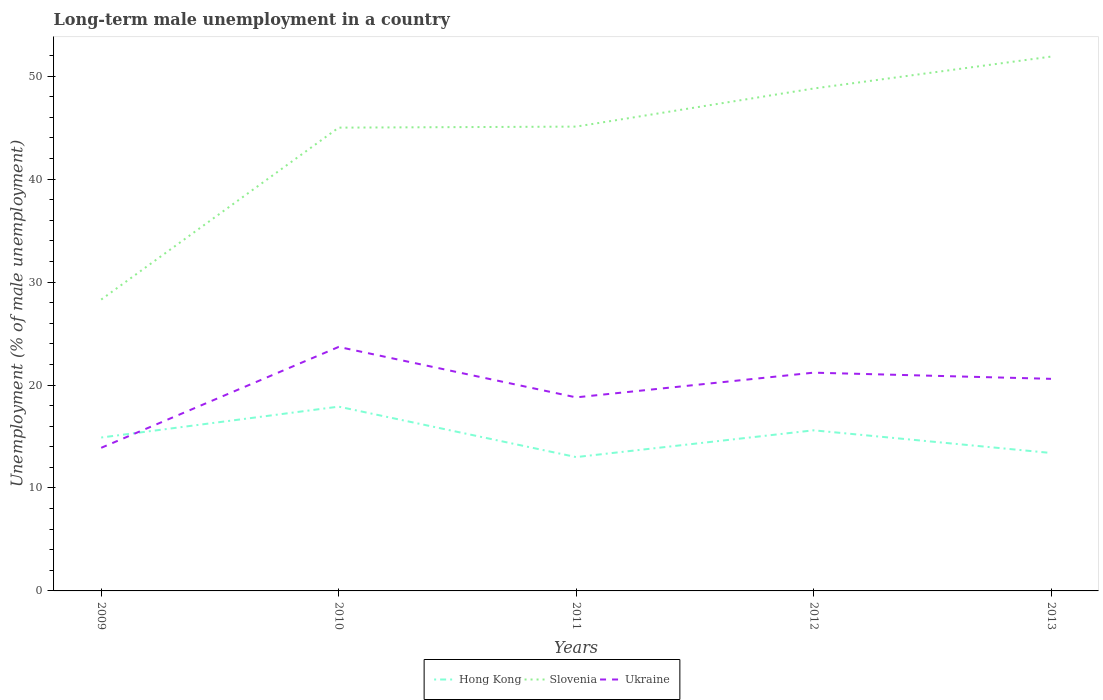How many different coloured lines are there?
Your answer should be compact. 3. Does the line corresponding to Hong Kong intersect with the line corresponding to Slovenia?
Provide a succinct answer. No. Is the number of lines equal to the number of legend labels?
Offer a terse response. Yes. Across all years, what is the maximum percentage of long-term unemployed male population in Hong Kong?
Your answer should be compact. 13. In which year was the percentage of long-term unemployed male population in Hong Kong maximum?
Your response must be concise. 2011. What is the total percentage of long-term unemployed male population in Hong Kong in the graph?
Offer a very short reply. 2.3. What is the difference between the highest and the second highest percentage of long-term unemployed male population in Slovenia?
Provide a short and direct response. 23.6. What is the difference between the highest and the lowest percentage of long-term unemployed male population in Slovenia?
Provide a short and direct response. 4. Is the percentage of long-term unemployed male population in Slovenia strictly greater than the percentage of long-term unemployed male population in Hong Kong over the years?
Your response must be concise. No. How many years are there in the graph?
Give a very brief answer. 5. Where does the legend appear in the graph?
Your response must be concise. Bottom center. How are the legend labels stacked?
Offer a terse response. Horizontal. What is the title of the graph?
Keep it short and to the point. Long-term male unemployment in a country. What is the label or title of the X-axis?
Ensure brevity in your answer.  Years. What is the label or title of the Y-axis?
Your answer should be compact. Unemployment (% of male unemployment). What is the Unemployment (% of male unemployment) of Hong Kong in 2009?
Ensure brevity in your answer.  14.9. What is the Unemployment (% of male unemployment) in Slovenia in 2009?
Provide a short and direct response. 28.3. What is the Unemployment (% of male unemployment) in Ukraine in 2009?
Make the answer very short. 13.9. What is the Unemployment (% of male unemployment) of Hong Kong in 2010?
Offer a very short reply. 17.9. What is the Unemployment (% of male unemployment) in Ukraine in 2010?
Your answer should be very brief. 23.7. What is the Unemployment (% of male unemployment) in Slovenia in 2011?
Offer a very short reply. 45.1. What is the Unemployment (% of male unemployment) in Ukraine in 2011?
Keep it short and to the point. 18.8. What is the Unemployment (% of male unemployment) of Hong Kong in 2012?
Your answer should be compact. 15.6. What is the Unemployment (% of male unemployment) in Slovenia in 2012?
Your response must be concise. 48.8. What is the Unemployment (% of male unemployment) in Ukraine in 2012?
Your answer should be very brief. 21.2. What is the Unemployment (% of male unemployment) in Hong Kong in 2013?
Give a very brief answer. 13.4. What is the Unemployment (% of male unemployment) of Slovenia in 2013?
Offer a very short reply. 51.9. What is the Unemployment (% of male unemployment) of Ukraine in 2013?
Provide a short and direct response. 20.6. Across all years, what is the maximum Unemployment (% of male unemployment) in Hong Kong?
Your response must be concise. 17.9. Across all years, what is the maximum Unemployment (% of male unemployment) in Slovenia?
Offer a terse response. 51.9. Across all years, what is the maximum Unemployment (% of male unemployment) of Ukraine?
Keep it short and to the point. 23.7. Across all years, what is the minimum Unemployment (% of male unemployment) of Hong Kong?
Offer a terse response. 13. Across all years, what is the minimum Unemployment (% of male unemployment) of Slovenia?
Your answer should be compact. 28.3. Across all years, what is the minimum Unemployment (% of male unemployment) in Ukraine?
Provide a short and direct response. 13.9. What is the total Unemployment (% of male unemployment) of Hong Kong in the graph?
Provide a short and direct response. 74.8. What is the total Unemployment (% of male unemployment) in Slovenia in the graph?
Provide a short and direct response. 219.1. What is the total Unemployment (% of male unemployment) in Ukraine in the graph?
Your response must be concise. 98.2. What is the difference between the Unemployment (% of male unemployment) of Slovenia in 2009 and that in 2010?
Your answer should be compact. -16.7. What is the difference between the Unemployment (% of male unemployment) of Ukraine in 2009 and that in 2010?
Make the answer very short. -9.8. What is the difference between the Unemployment (% of male unemployment) in Slovenia in 2009 and that in 2011?
Ensure brevity in your answer.  -16.8. What is the difference between the Unemployment (% of male unemployment) in Ukraine in 2009 and that in 2011?
Give a very brief answer. -4.9. What is the difference between the Unemployment (% of male unemployment) in Slovenia in 2009 and that in 2012?
Provide a succinct answer. -20.5. What is the difference between the Unemployment (% of male unemployment) in Hong Kong in 2009 and that in 2013?
Your answer should be compact. 1.5. What is the difference between the Unemployment (% of male unemployment) in Slovenia in 2009 and that in 2013?
Your answer should be very brief. -23.6. What is the difference between the Unemployment (% of male unemployment) in Ukraine in 2009 and that in 2013?
Keep it short and to the point. -6.7. What is the difference between the Unemployment (% of male unemployment) in Hong Kong in 2010 and that in 2011?
Provide a short and direct response. 4.9. What is the difference between the Unemployment (% of male unemployment) of Hong Kong in 2010 and that in 2012?
Offer a terse response. 2.3. What is the difference between the Unemployment (% of male unemployment) of Slovenia in 2010 and that in 2012?
Your answer should be very brief. -3.8. What is the difference between the Unemployment (% of male unemployment) of Ukraine in 2010 and that in 2012?
Your response must be concise. 2.5. What is the difference between the Unemployment (% of male unemployment) in Hong Kong in 2011 and that in 2012?
Give a very brief answer. -2.6. What is the difference between the Unemployment (% of male unemployment) of Slovenia in 2011 and that in 2012?
Offer a very short reply. -3.7. What is the difference between the Unemployment (% of male unemployment) in Ukraine in 2011 and that in 2012?
Provide a succinct answer. -2.4. What is the difference between the Unemployment (% of male unemployment) in Hong Kong in 2011 and that in 2013?
Provide a succinct answer. -0.4. What is the difference between the Unemployment (% of male unemployment) in Ukraine in 2011 and that in 2013?
Provide a succinct answer. -1.8. What is the difference between the Unemployment (% of male unemployment) of Slovenia in 2012 and that in 2013?
Your answer should be compact. -3.1. What is the difference between the Unemployment (% of male unemployment) in Ukraine in 2012 and that in 2013?
Offer a terse response. 0.6. What is the difference between the Unemployment (% of male unemployment) in Hong Kong in 2009 and the Unemployment (% of male unemployment) in Slovenia in 2010?
Ensure brevity in your answer.  -30.1. What is the difference between the Unemployment (% of male unemployment) in Hong Kong in 2009 and the Unemployment (% of male unemployment) in Slovenia in 2011?
Ensure brevity in your answer.  -30.2. What is the difference between the Unemployment (% of male unemployment) in Hong Kong in 2009 and the Unemployment (% of male unemployment) in Slovenia in 2012?
Make the answer very short. -33.9. What is the difference between the Unemployment (% of male unemployment) of Hong Kong in 2009 and the Unemployment (% of male unemployment) of Ukraine in 2012?
Offer a terse response. -6.3. What is the difference between the Unemployment (% of male unemployment) in Hong Kong in 2009 and the Unemployment (% of male unemployment) in Slovenia in 2013?
Make the answer very short. -37. What is the difference between the Unemployment (% of male unemployment) of Hong Kong in 2010 and the Unemployment (% of male unemployment) of Slovenia in 2011?
Your response must be concise. -27.2. What is the difference between the Unemployment (% of male unemployment) of Slovenia in 2010 and the Unemployment (% of male unemployment) of Ukraine in 2011?
Provide a succinct answer. 26.2. What is the difference between the Unemployment (% of male unemployment) of Hong Kong in 2010 and the Unemployment (% of male unemployment) of Slovenia in 2012?
Your response must be concise. -30.9. What is the difference between the Unemployment (% of male unemployment) of Hong Kong in 2010 and the Unemployment (% of male unemployment) of Ukraine in 2012?
Offer a very short reply. -3.3. What is the difference between the Unemployment (% of male unemployment) in Slovenia in 2010 and the Unemployment (% of male unemployment) in Ukraine in 2012?
Ensure brevity in your answer.  23.8. What is the difference between the Unemployment (% of male unemployment) in Hong Kong in 2010 and the Unemployment (% of male unemployment) in Slovenia in 2013?
Your response must be concise. -34. What is the difference between the Unemployment (% of male unemployment) of Slovenia in 2010 and the Unemployment (% of male unemployment) of Ukraine in 2013?
Ensure brevity in your answer.  24.4. What is the difference between the Unemployment (% of male unemployment) of Hong Kong in 2011 and the Unemployment (% of male unemployment) of Slovenia in 2012?
Your answer should be very brief. -35.8. What is the difference between the Unemployment (% of male unemployment) in Slovenia in 2011 and the Unemployment (% of male unemployment) in Ukraine in 2012?
Offer a terse response. 23.9. What is the difference between the Unemployment (% of male unemployment) in Hong Kong in 2011 and the Unemployment (% of male unemployment) in Slovenia in 2013?
Keep it short and to the point. -38.9. What is the difference between the Unemployment (% of male unemployment) of Hong Kong in 2012 and the Unemployment (% of male unemployment) of Slovenia in 2013?
Keep it short and to the point. -36.3. What is the difference between the Unemployment (% of male unemployment) in Slovenia in 2012 and the Unemployment (% of male unemployment) in Ukraine in 2013?
Offer a very short reply. 28.2. What is the average Unemployment (% of male unemployment) of Hong Kong per year?
Make the answer very short. 14.96. What is the average Unemployment (% of male unemployment) in Slovenia per year?
Give a very brief answer. 43.82. What is the average Unemployment (% of male unemployment) of Ukraine per year?
Keep it short and to the point. 19.64. In the year 2009, what is the difference between the Unemployment (% of male unemployment) in Hong Kong and Unemployment (% of male unemployment) in Ukraine?
Provide a short and direct response. 1. In the year 2010, what is the difference between the Unemployment (% of male unemployment) in Hong Kong and Unemployment (% of male unemployment) in Slovenia?
Ensure brevity in your answer.  -27.1. In the year 2010, what is the difference between the Unemployment (% of male unemployment) of Hong Kong and Unemployment (% of male unemployment) of Ukraine?
Your answer should be very brief. -5.8. In the year 2010, what is the difference between the Unemployment (% of male unemployment) in Slovenia and Unemployment (% of male unemployment) in Ukraine?
Ensure brevity in your answer.  21.3. In the year 2011, what is the difference between the Unemployment (% of male unemployment) of Hong Kong and Unemployment (% of male unemployment) of Slovenia?
Your response must be concise. -32.1. In the year 2011, what is the difference between the Unemployment (% of male unemployment) in Hong Kong and Unemployment (% of male unemployment) in Ukraine?
Make the answer very short. -5.8. In the year 2011, what is the difference between the Unemployment (% of male unemployment) of Slovenia and Unemployment (% of male unemployment) of Ukraine?
Give a very brief answer. 26.3. In the year 2012, what is the difference between the Unemployment (% of male unemployment) of Hong Kong and Unemployment (% of male unemployment) of Slovenia?
Provide a short and direct response. -33.2. In the year 2012, what is the difference between the Unemployment (% of male unemployment) in Slovenia and Unemployment (% of male unemployment) in Ukraine?
Make the answer very short. 27.6. In the year 2013, what is the difference between the Unemployment (% of male unemployment) of Hong Kong and Unemployment (% of male unemployment) of Slovenia?
Provide a short and direct response. -38.5. In the year 2013, what is the difference between the Unemployment (% of male unemployment) of Slovenia and Unemployment (% of male unemployment) of Ukraine?
Offer a terse response. 31.3. What is the ratio of the Unemployment (% of male unemployment) of Hong Kong in 2009 to that in 2010?
Ensure brevity in your answer.  0.83. What is the ratio of the Unemployment (% of male unemployment) of Slovenia in 2009 to that in 2010?
Offer a very short reply. 0.63. What is the ratio of the Unemployment (% of male unemployment) of Ukraine in 2009 to that in 2010?
Provide a short and direct response. 0.59. What is the ratio of the Unemployment (% of male unemployment) in Hong Kong in 2009 to that in 2011?
Make the answer very short. 1.15. What is the ratio of the Unemployment (% of male unemployment) of Slovenia in 2009 to that in 2011?
Give a very brief answer. 0.63. What is the ratio of the Unemployment (% of male unemployment) in Ukraine in 2009 to that in 2011?
Your response must be concise. 0.74. What is the ratio of the Unemployment (% of male unemployment) in Hong Kong in 2009 to that in 2012?
Offer a very short reply. 0.96. What is the ratio of the Unemployment (% of male unemployment) of Slovenia in 2009 to that in 2012?
Ensure brevity in your answer.  0.58. What is the ratio of the Unemployment (% of male unemployment) in Ukraine in 2009 to that in 2012?
Your answer should be compact. 0.66. What is the ratio of the Unemployment (% of male unemployment) of Hong Kong in 2009 to that in 2013?
Keep it short and to the point. 1.11. What is the ratio of the Unemployment (% of male unemployment) in Slovenia in 2009 to that in 2013?
Your response must be concise. 0.55. What is the ratio of the Unemployment (% of male unemployment) of Ukraine in 2009 to that in 2013?
Your response must be concise. 0.67. What is the ratio of the Unemployment (% of male unemployment) in Hong Kong in 2010 to that in 2011?
Your response must be concise. 1.38. What is the ratio of the Unemployment (% of male unemployment) in Slovenia in 2010 to that in 2011?
Keep it short and to the point. 1. What is the ratio of the Unemployment (% of male unemployment) in Ukraine in 2010 to that in 2011?
Make the answer very short. 1.26. What is the ratio of the Unemployment (% of male unemployment) of Hong Kong in 2010 to that in 2012?
Your answer should be very brief. 1.15. What is the ratio of the Unemployment (% of male unemployment) in Slovenia in 2010 to that in 2012?
Keep it short and to the point. 0.92. What is the ratio of the Unemployment (% of male unemployment) in Ukraine in 2010 to that in 2012?
Offer a very short reply. 1.12. What is the ratio of the Unemployment (% of male unemployment) of Hong Kong in 2010 to that in 2013?
Keep it short and to the point. 1.34. What is the ratio of the Unemployment (% of male unemployment) in Slovenia in 2010 to that in 2013?
Ensure brevity in your answer.  0.87. What is the ratio of the Unemployment (% of male unemployment) of Ukraine in 2010 to that in 2013?
Provide a succinct answer. 1.15. What is the ratio of the Unemployment (% of male unemployment) in Hong Kong in 2011 to that in 2012?
Ensure brevity in your answer.  0.83. What is the ratio of the Unemployment (% of male unemployment) in Slovenia in 2011 to that in 2012?
Ensure brevity in your answer.  0.92. What is the ratio of the Unemployment (% of male unemployment) of Ukraine in 2011 to that in 2012?
Your answer should be very brief. 0.89. What is the ratio of the Unemployment (% of male unemployment) in Hong Kong in 2011 to that in 2013?
Ensure brevity in your answer.  0.97. What is the ratio of the Unemployment (% of male unemployment) of Slovenia in 2011 to that in 2013?
Your response must be concise. 0.87. What is the ratio of the Unemployment (% of male unemployment) in Ukraine in 2011 to that in 2013?
Provide a short and direct response. 0.91. What is the ratio of the Unemployment (% of male unemployment) in Hong Kong in 2012 to that in 2013?
Offer a very short reply. 1.16. What is the ratio of the Unemployment (% of male unemployment) of Slovenia in 2012 to that in 2013?
Your answer should be very brief. 0.94. What is the ratio of the Unemployment (% of male unemployment) of Ukraine in 2012 to that in 2013?
Your answer should be compact. 1.03. What is the difference between the highest and the second highest Unemployment (% of male unemployment) in Slovenia?
Your answer should be very brief. 3.1. What is the difference between the highest and the second highest Unemployment (% of male unemployment) of Ukraine?
Your response must be concise. 2.5. What is the difference between the highest and the lowest Unemployment (% of male unemployment) of Hong Kong?
Offer a very short reply. 4.9. What is the difference between the highest and the lowest Unemployment (% of male unemployment) of Slovenia?
Offer a terse response. 23.6. 